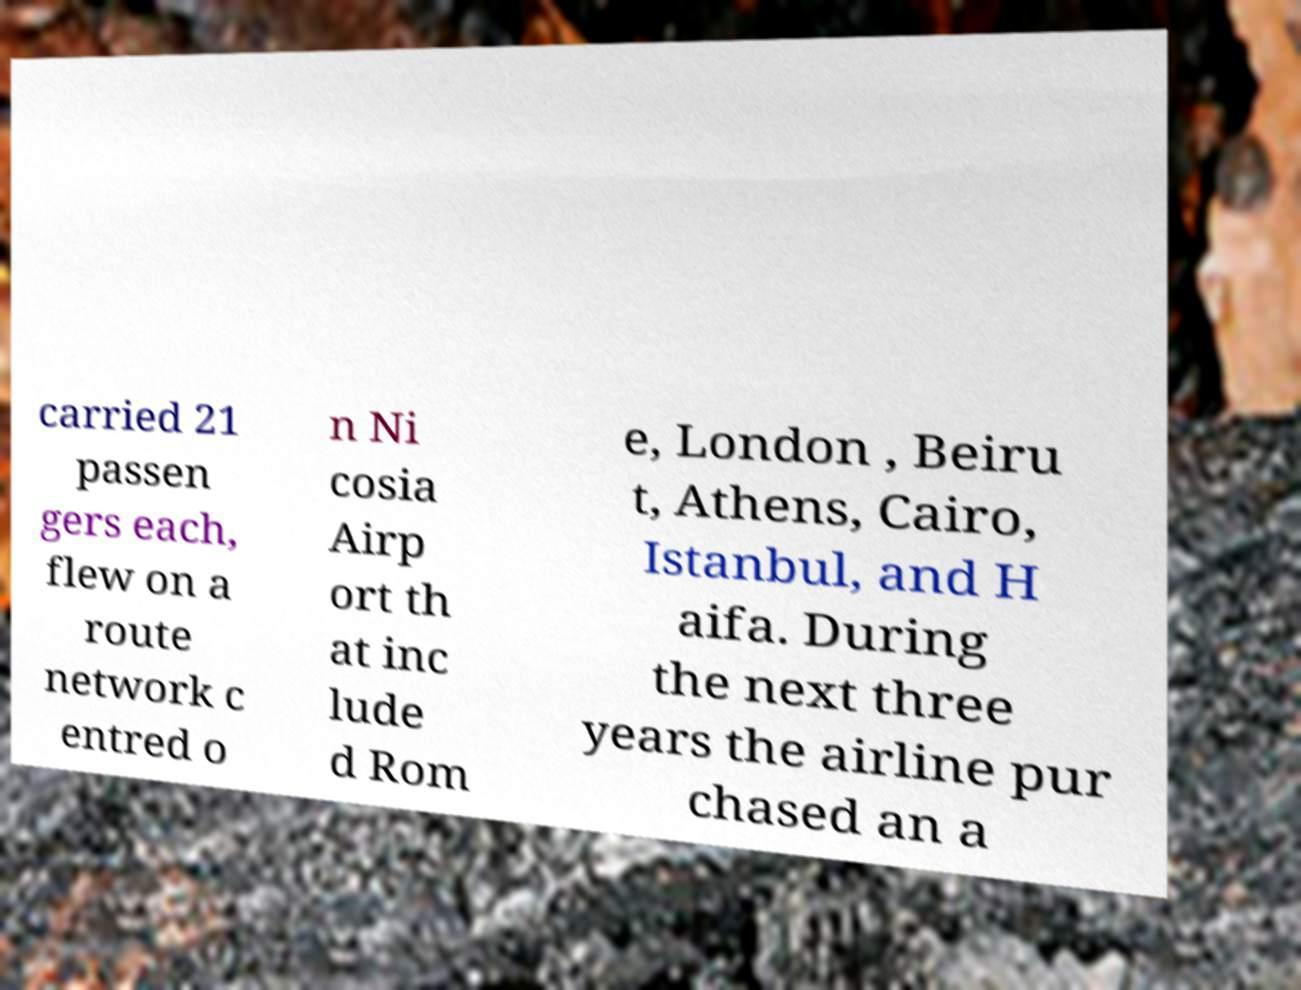What messages or text are displayed in this image? I need them in a readable, typed format. carried 21 passen gers each, flew on a route network c entred o n Ni cosia Airp ort th at inc lude d Rom e, London , Beiru t, Athens, Cairo, Istanbul, and H aifa. During the next three years the airline pur chased an a 